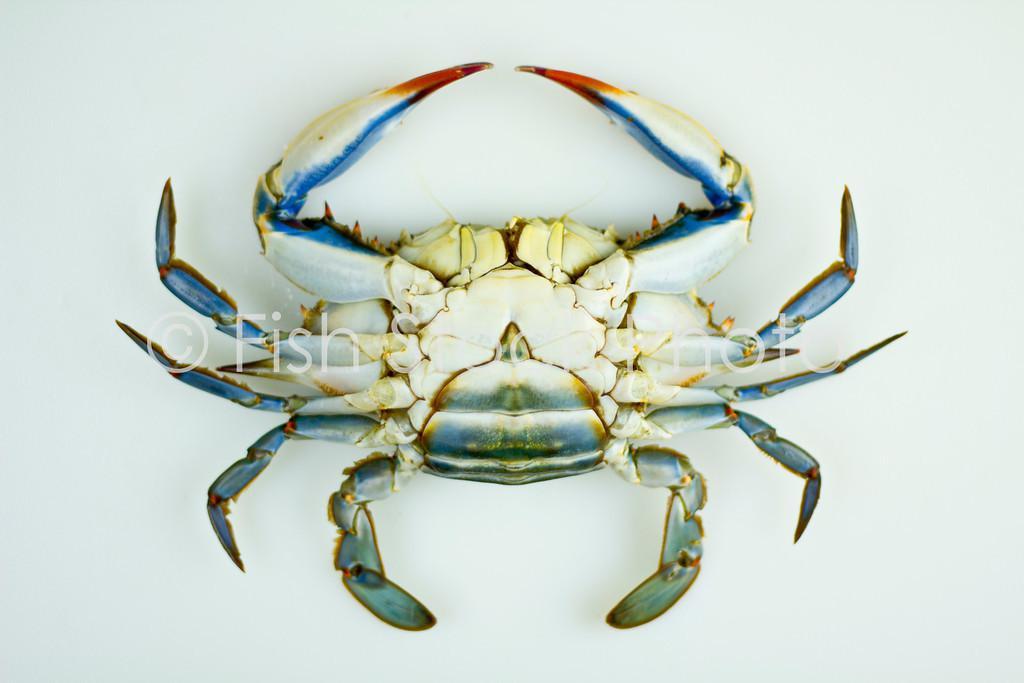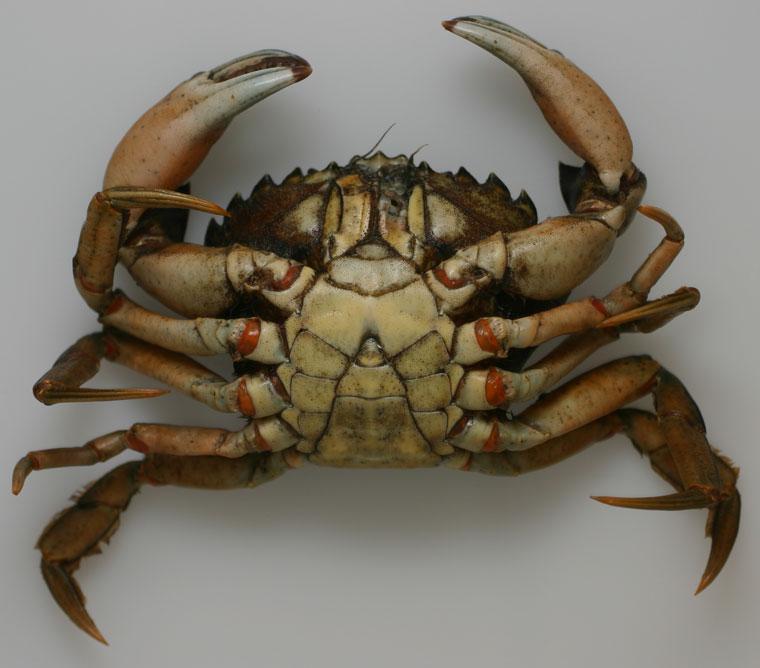The first image is the image on the left, the second image is the image on the right. Assess this claim about the two images: "Each image is a bottom view of a single crab with its head at the top of the image and its front claws pointed toward each other.". Correct or not? Answer yes or no. Yes. The first image is the image on the left, the second image is the image on the right. Analyze the images presented: Is the assertion "Both pictures show the underside of one crab and all are positioned in the same way." valid? Answer yes or no. Yes. 